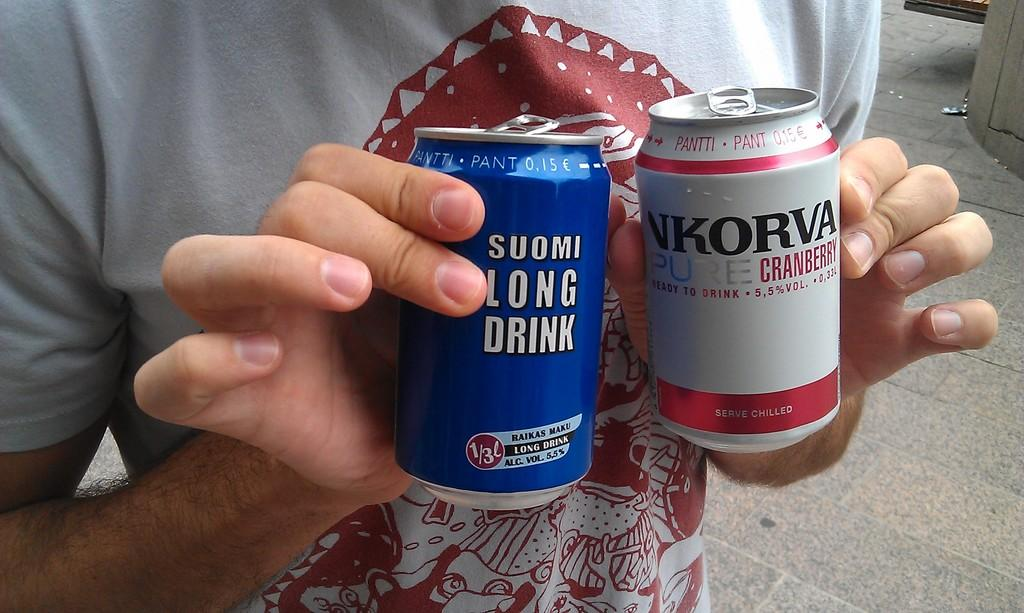<image>
Write a terse but informative summary of the picture. Person holding a blue Suomi Long Drink and a white NKorva Cranberry drink. 